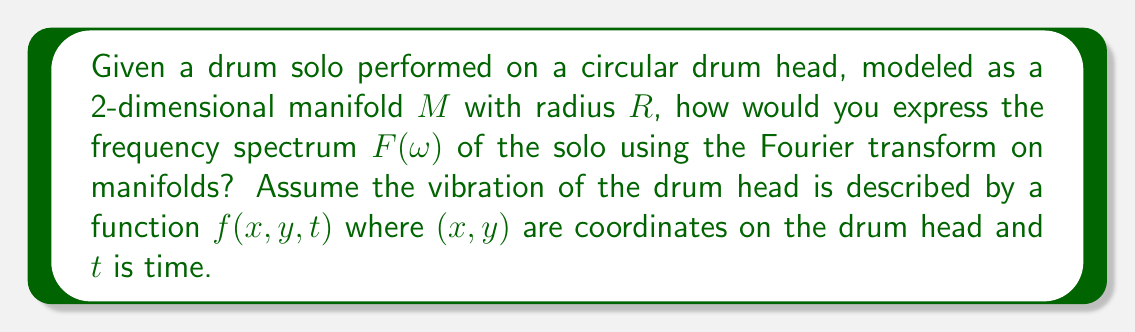Can you answer this question? To analyze the frequency spectrum of a drum solo using Fourier transforms on manifolds, we need to follow these steps:

1) First, we need to recognize that the drum head is a 2-dimensional manifold $M$, specifically a circular disk with radius $R$. The vibration of the drum head can be described by a function $f(x,y,t)$ where $(x,y)$ are coordinates on the drum head and $t$ is time.

2) The Fourier transform on a manifold is defined as:

   $$F(\omega) = \int_M f(p) e^{-i\omega \cdot p} d\mu(p)$$

   where $p$ represents a point on the manifold, $\omega$ is the frequency, and $d\mu(p)$ is the measure on the manifold.

3) For our circular drum head, we can use polar coordinates $(r,\theta)$ instead of $(x,y)$. The measure in polar coordinates is $d\mu(p) = r dr d\theta$.

4) We need to consider the time dependence of $f$. We can perform a separate Fourier transform in time:

   $$f(r,\theta,\omega) = \int_{-\infty}^{\infty} f(r,\theta,t) e^{-i\omega t} dt$$

5) Now, we can express the full Fourier transform on our manifold as:

   $$F(\omega_r, \omega_\theta, \omega) = \int_0^R \int_0^{2\pi} f(r,\theta,\omega) e^{-i(\omega_r r + \omega_\theta \theta)} r dr d\theta$$

   where $\omega_r$ and $\omega_\theta$ represent the spatial frequencies in the radial and angular directions respectively.

6) This expression gives us the full frequency spectrum of the drum solo, including both temporal and spatial frequencies.

7) To get the total energy at each frequency $\omega$, we would integrate over all spatial frequencies:

   $$E(\omega) = \int_{-\infty}^{\infty} \int_{-\infty}^{\infty} |F(\omega_r, \omega_\theta, \omega)|^2 d\omega_r d\omega_\theta$$

This approach allows us to analyze not just the temporal frequencies of the drum solo, but also how different parts of the drum head are vibrating at different frequencies.
Answer: The frequency spectrum $F(\omega)$ of the drum solo can be expressed as:

$$F(\omega_r, \omega_\theta, \omega) = \int_0^R \int_0^{2\pi} \left(\int_{-\infty}^{\infty} f(r,\theta,t) e^{-i\omega t} dt\right) e^{-i(\omega_r r + \omega_\theta \theta)} r dr d\theta$$

where $R$ is the radius of the drum head, $\omega$ is the temporal frequency, and $\omega_r$ and $\omega_\theta$ are spatial frequencies in the radial and angular directions respectively. 